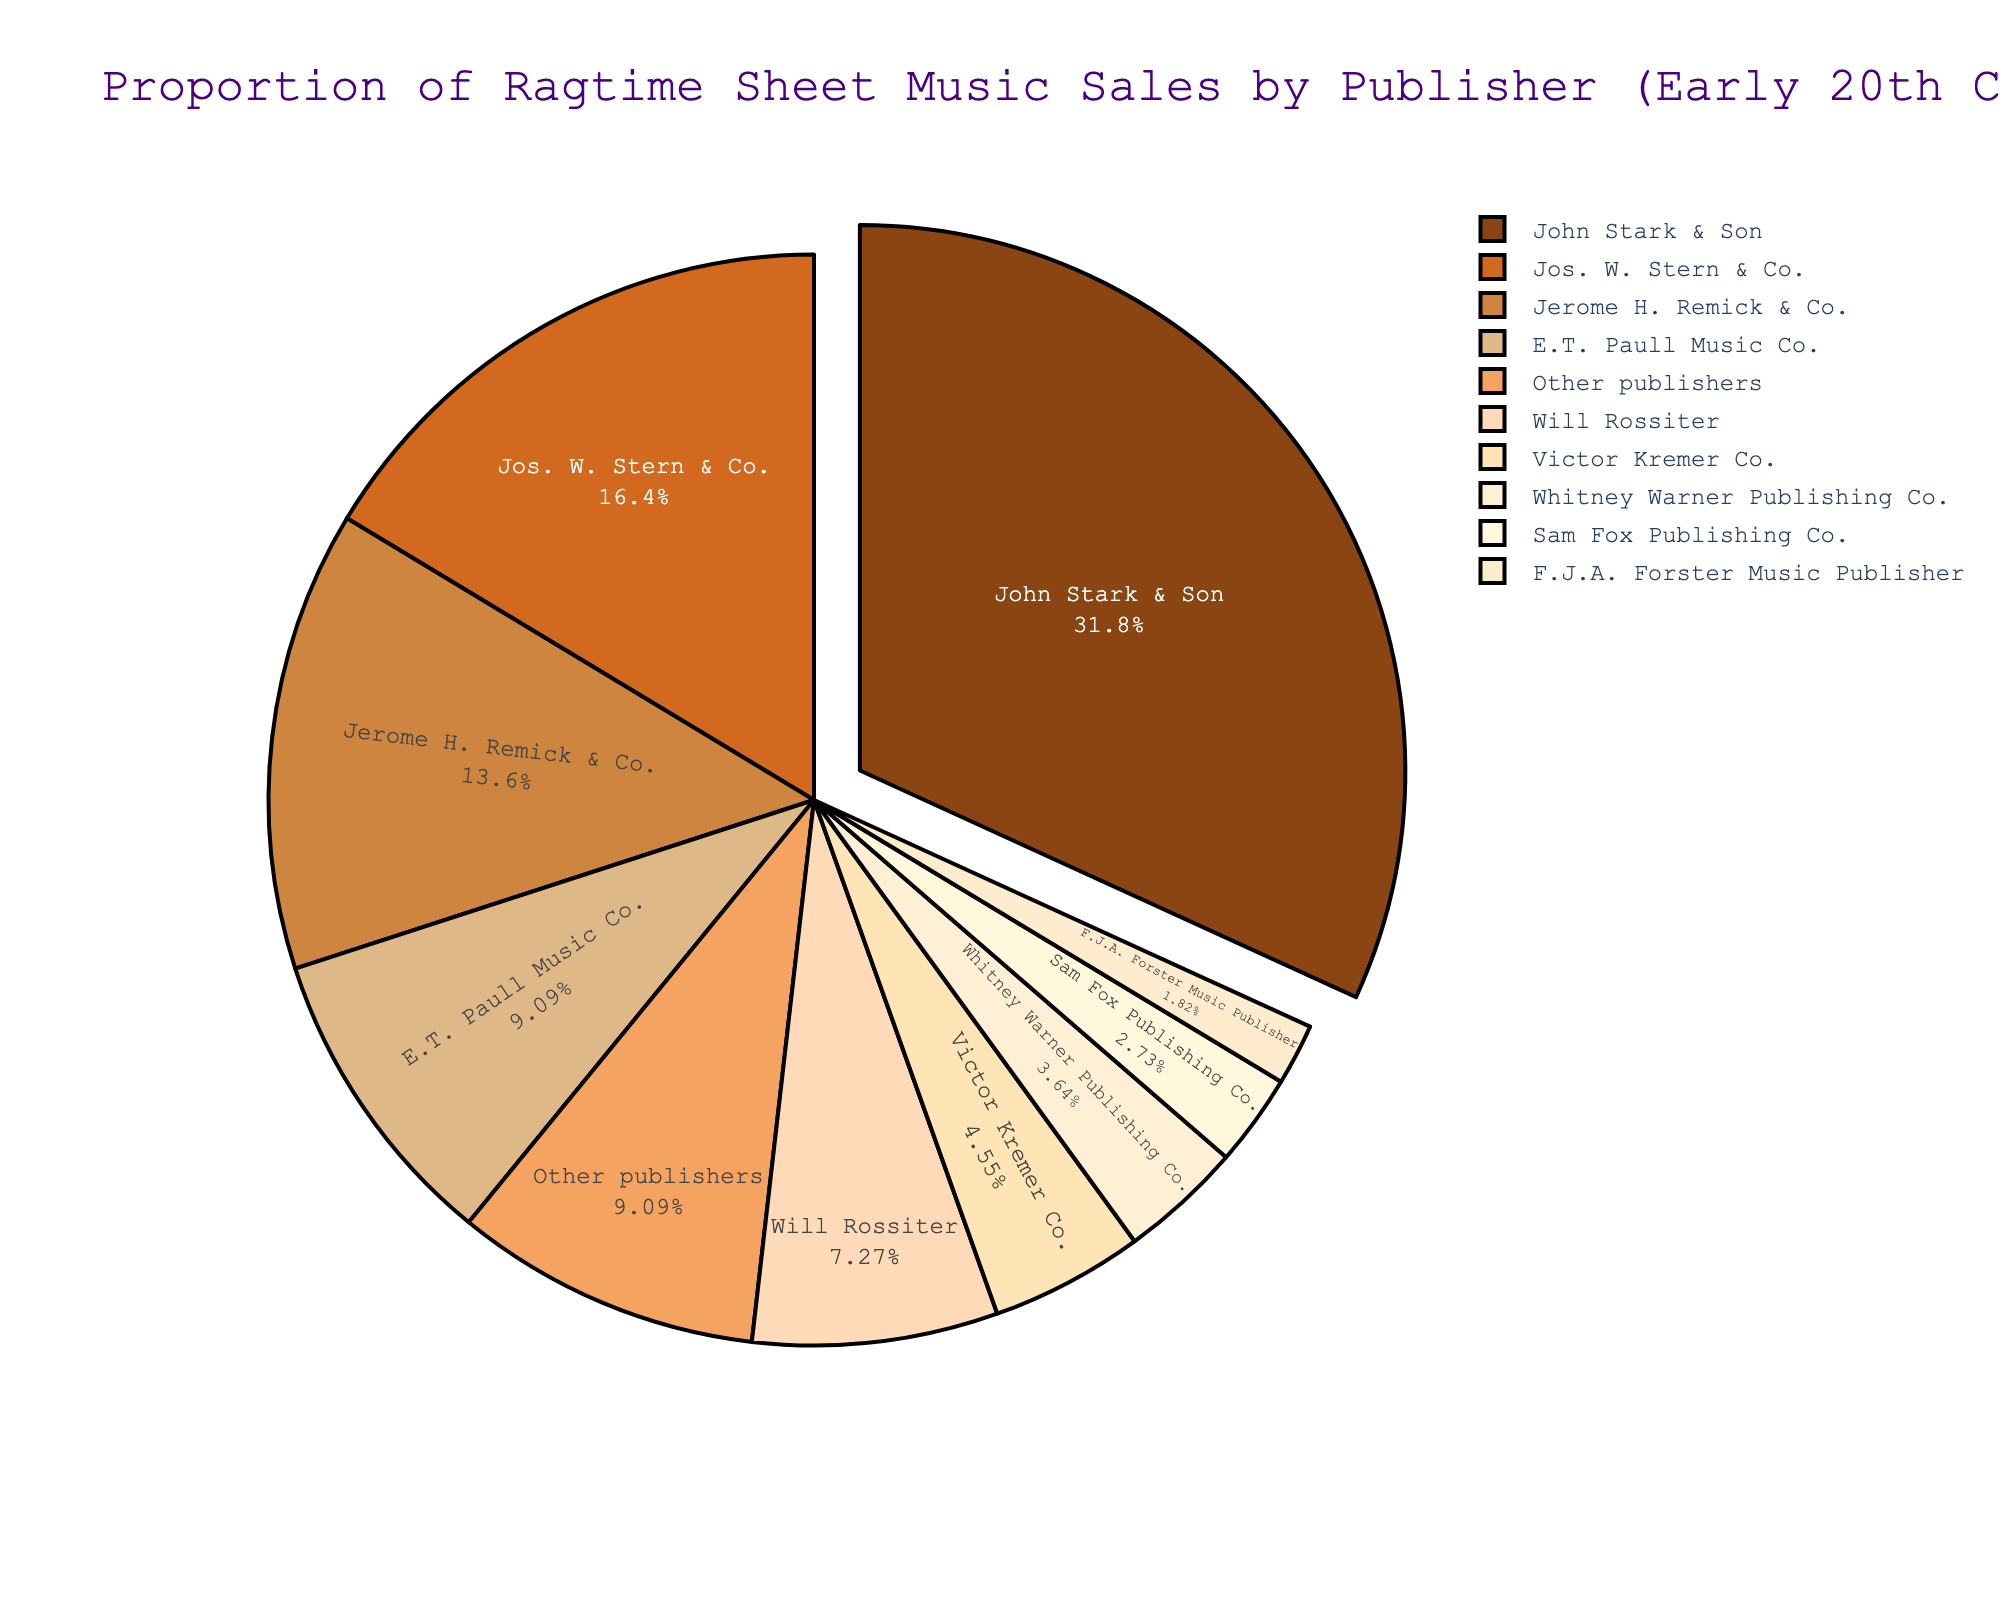which publisher has the highest proportion of ragtime sheet music sales? John Stark & Son has the largest pie slice in the chart, which is visually indicated by its size and the percentage value shown.
Answer: John Stark & Son how much more sheet music did John Stark & Son sell compared to Jos. W. Stern & Co.? John Stark & Son sold 35%, and Jos. W. Stern & Co. sold 18%. Subtracting the two percentages gives the difference: 35% - 18% = 17%.
Answer: 17% are there any publishers that sold the same proportion of sheet music? Looking at the chart, no two slices appear to be equal, and the percentages shown do not indicate any duplicate values.
Answer: No what is the total proportion of sales for the top three publishers? The top three publishers are John Stark & Son (35%), Jos. W. Stern & Co. (18%), and Jerome H. Remick & Co. (15%). Adding these percentages gives: 35% + 18% + 15% = 68%.
Answer: 68% how do the sales of Will Rossiter compare to Victor Kremer Co.? Will Rossiter has a slice representing 8%, whereas Victor Kremer Co. has a slice representing 5%. The visual and percentage labels indicate that Will Rossiter sold more by 3%.
Answer: Will Rossiter sold 3% more what color represents the sales of E.T. Paull Music Co.? E.T. Paull Music Co.'s segment of the pie chart is colored in a lighter brown shade, specifically the fourth color in the provided custom palette. To confirm, we can match the category label.
Answer: Light brown how many publishers contributed to more than 10% of the sales each? John Stark & Son (35%), Jos. W. Stern & Co. (18%), and Jerome H. Remick & Co. (15%) are the only publishers exceeding 10%. Counting these gives three publishers.
Answer: Three what is the combined proportion of sales of the bottom three publishers? The bottom three publishers are F.J.A. Forster Music Publisher (2%), Sam Fox Publishing Co. (3%), and Whitney Warner Publishing Co. (4%). Adding these percentages gives: 2% + 3% + 4% = 9%.
Answer: 9% how does the proportion of 'Other publishers' compare to E.T. Paull Music Co.? 'Other publishers' have a 10% proportion, while E.T. Paull Music Co. also has 10%. The proportions are equal, as indicated by the labels.
Answer: Equal 